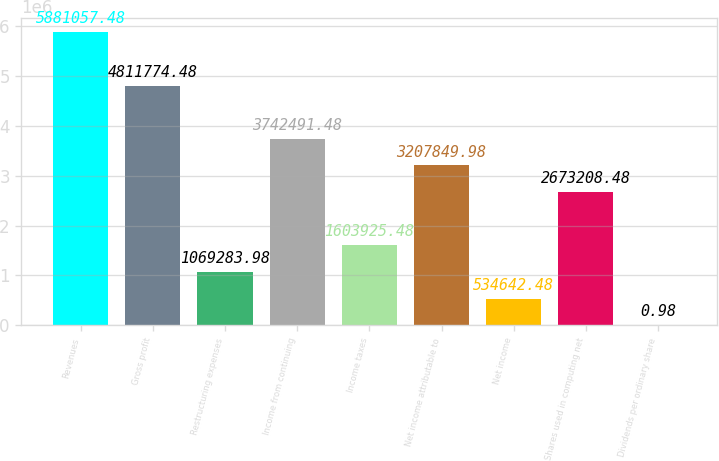Convert chart to OTSL. <chart><loc_0><loc_0><loc_500><loc_500><bar_chart><fcel>Revenues<fcel>Gross profit<fcel>Restructuring expenses<fcel>Income from continuing<fcel>Income taxes<fcel>Net income attributable to<fcel>Net income<fcel>Shares used in computing net<fcel>Dividends per ordinary share<nl><fcel>5.88106e+06<fcel>4.81177e+06<fcel>1.06928e+06<fcel>3.74249e+06<fcel>1.60393e+06<fcel>3.20785e+06<fcel>534642<fcel>2.67321e+06<fcel>0.98<nl></chart> 